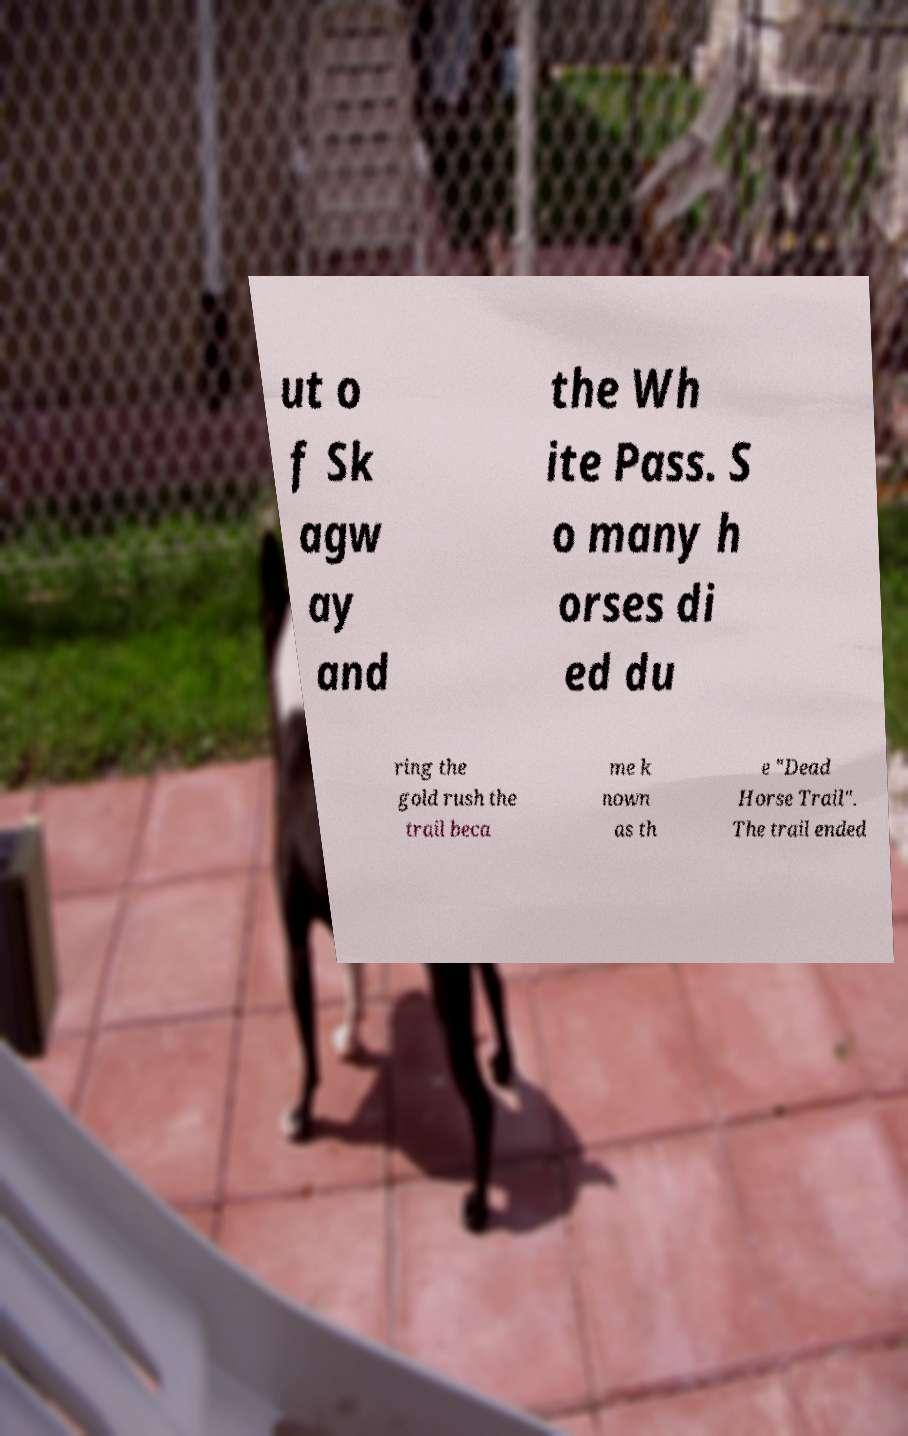Can you read and provide the text displayed in the image?This photo seems to have some interesting text. Can you extract and type it out for me? ut o f Sk agw ay and the Wh ite Pass. S o many h orses di ed du ring the gold rush the trail beca me k nown as th e "Dead Horse Trail". The trail ended 